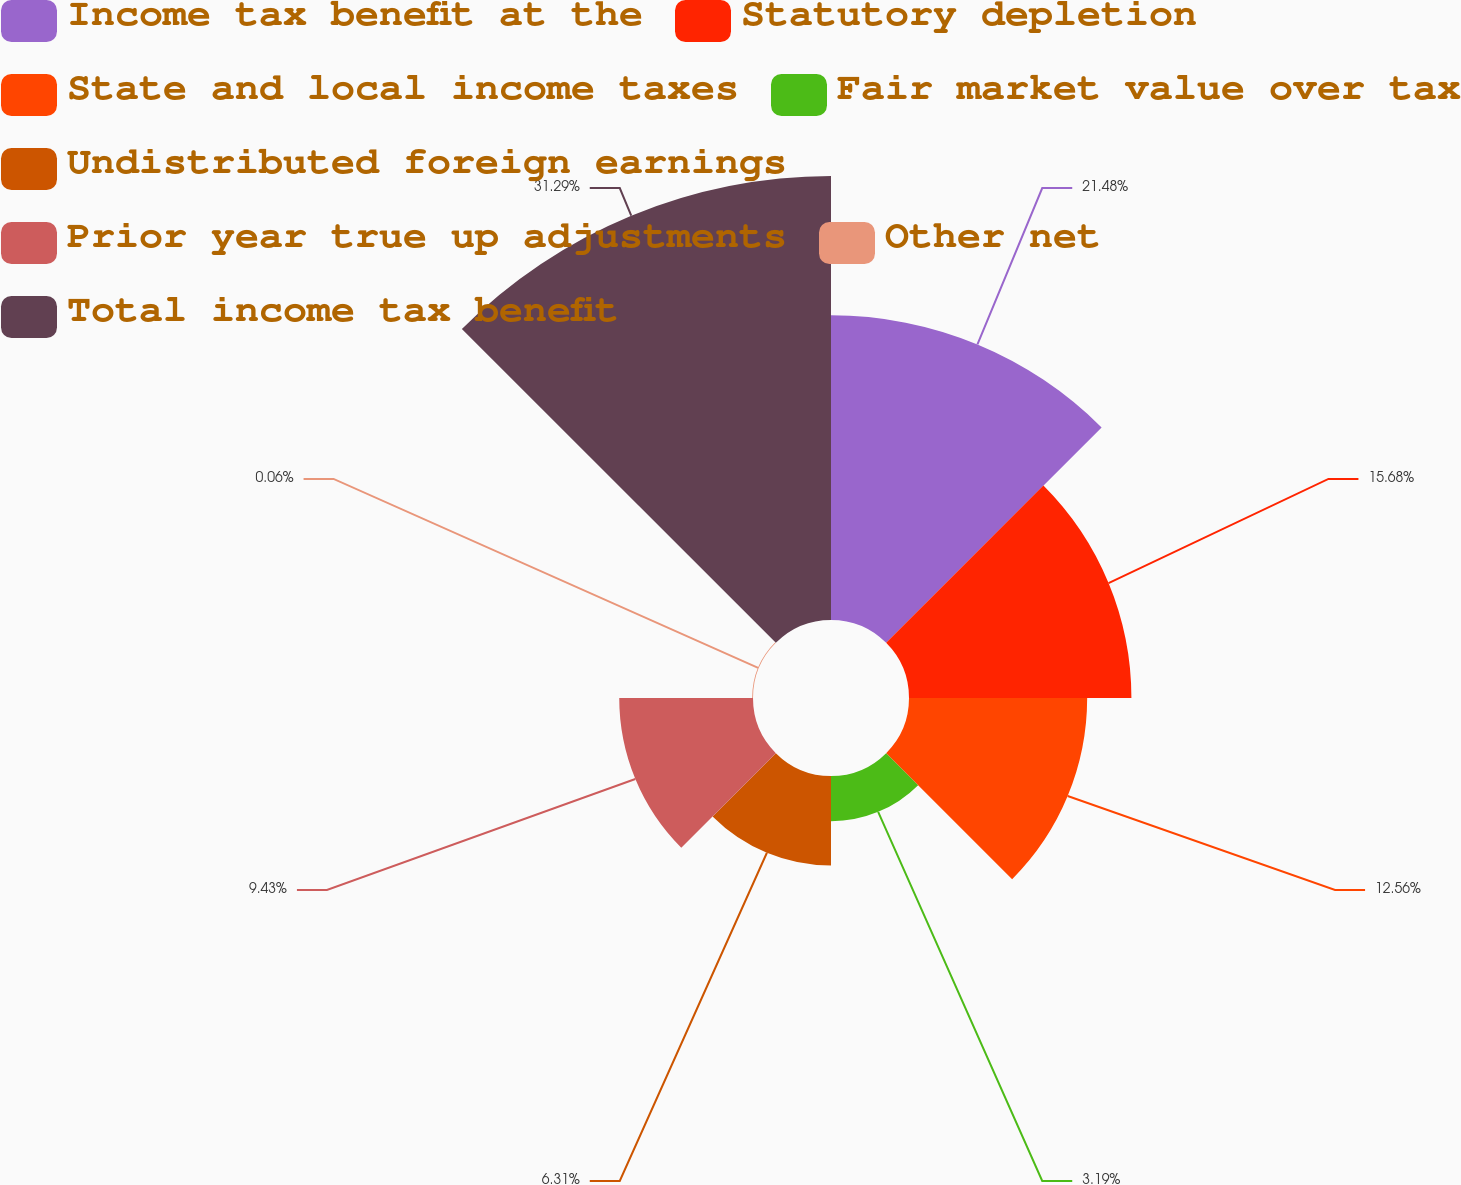Convert chart to OTSL. <chart><loc_0><loc_0><loc_500><loc_500><pie_chart><fcel>Income tax benefit at the<fcel>Statutory depletion<fcel>State and local income taxes<fcel>Fair market value over tax<fcel>Undistributed foreign earnings<fcel>Prior year true up adjustments<fcel>Other net<fcel>Total income tax benefit<nl><fcel>21.48%<fcel>15.68%<fcel>12.56%<fcel>3.19%<fcel>6.31%<fcel>9.43%<fcel>0.06%<fcel>31.3%<nl></chart> 